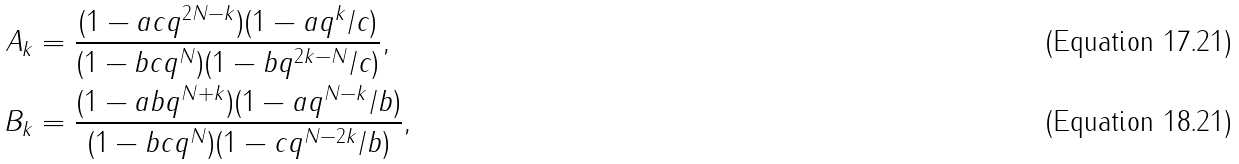Convert formula to latex. <formula><loc_0><loc_0><loc_500><loc_500>A _ { k } & = \frac { ( 1 - a c q ^ { 2 N - k } ) ( 1 - a q ^ { k } / c ) } { ( 1 - b c q ^ { N } ) ( 1 - b q ^ { 2 k - N } / c ) } , \\ B _ { k } & = \frac { ( 1 - a b q ^ { N + k } ) ( 1 - a q ^ { N - k } / b ) } { ( 1 - b c q ^ { N } ) ( 1 - c q ^ { N - 2 k } / b ) } ,</formula> 